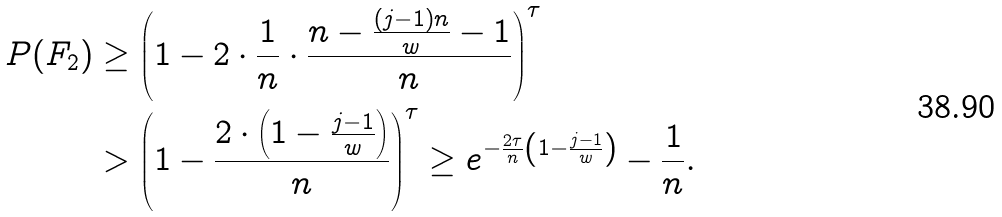<formula> <loc_0><loc_0><loc_500><loc_500>P ( F _ { 2 } ) & \geq \left ( 1 - 2 \cdot \frac { 1 } { n } \cdot \frac { n - \frac { ( j - 1 ) n } { w } - 1 } { n } \right ) ^ { \tau } \\ & > \left ( 1 - \frac { 2 \cdot \left ( 1 - \frac { j - 1 } { w } \right ) } { n } \right ) ^ { \tau } \geq e ^ { - \frac { 2 \tau } { n } \left ( 1 - \frac { j - 1 } { w } \right ) } - \frac { 1 } { n } .</formula> 